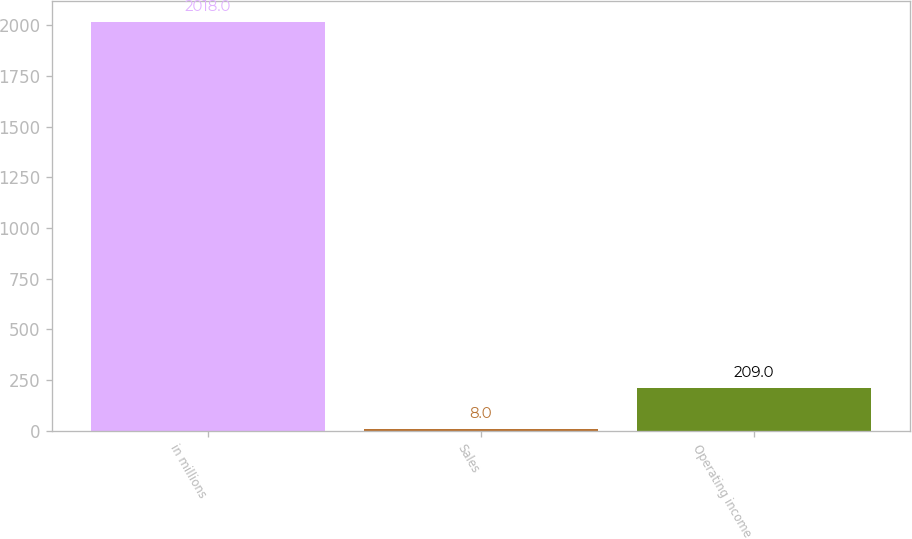Convert chart. <chart><loc_0><loc_0><loc_500><loc_500><bar_chart><fcel>in millions<fcel>Sales<fcel>Operating income<nl><fcel>2018<fcel>8<fcel>209<nl></chart> 